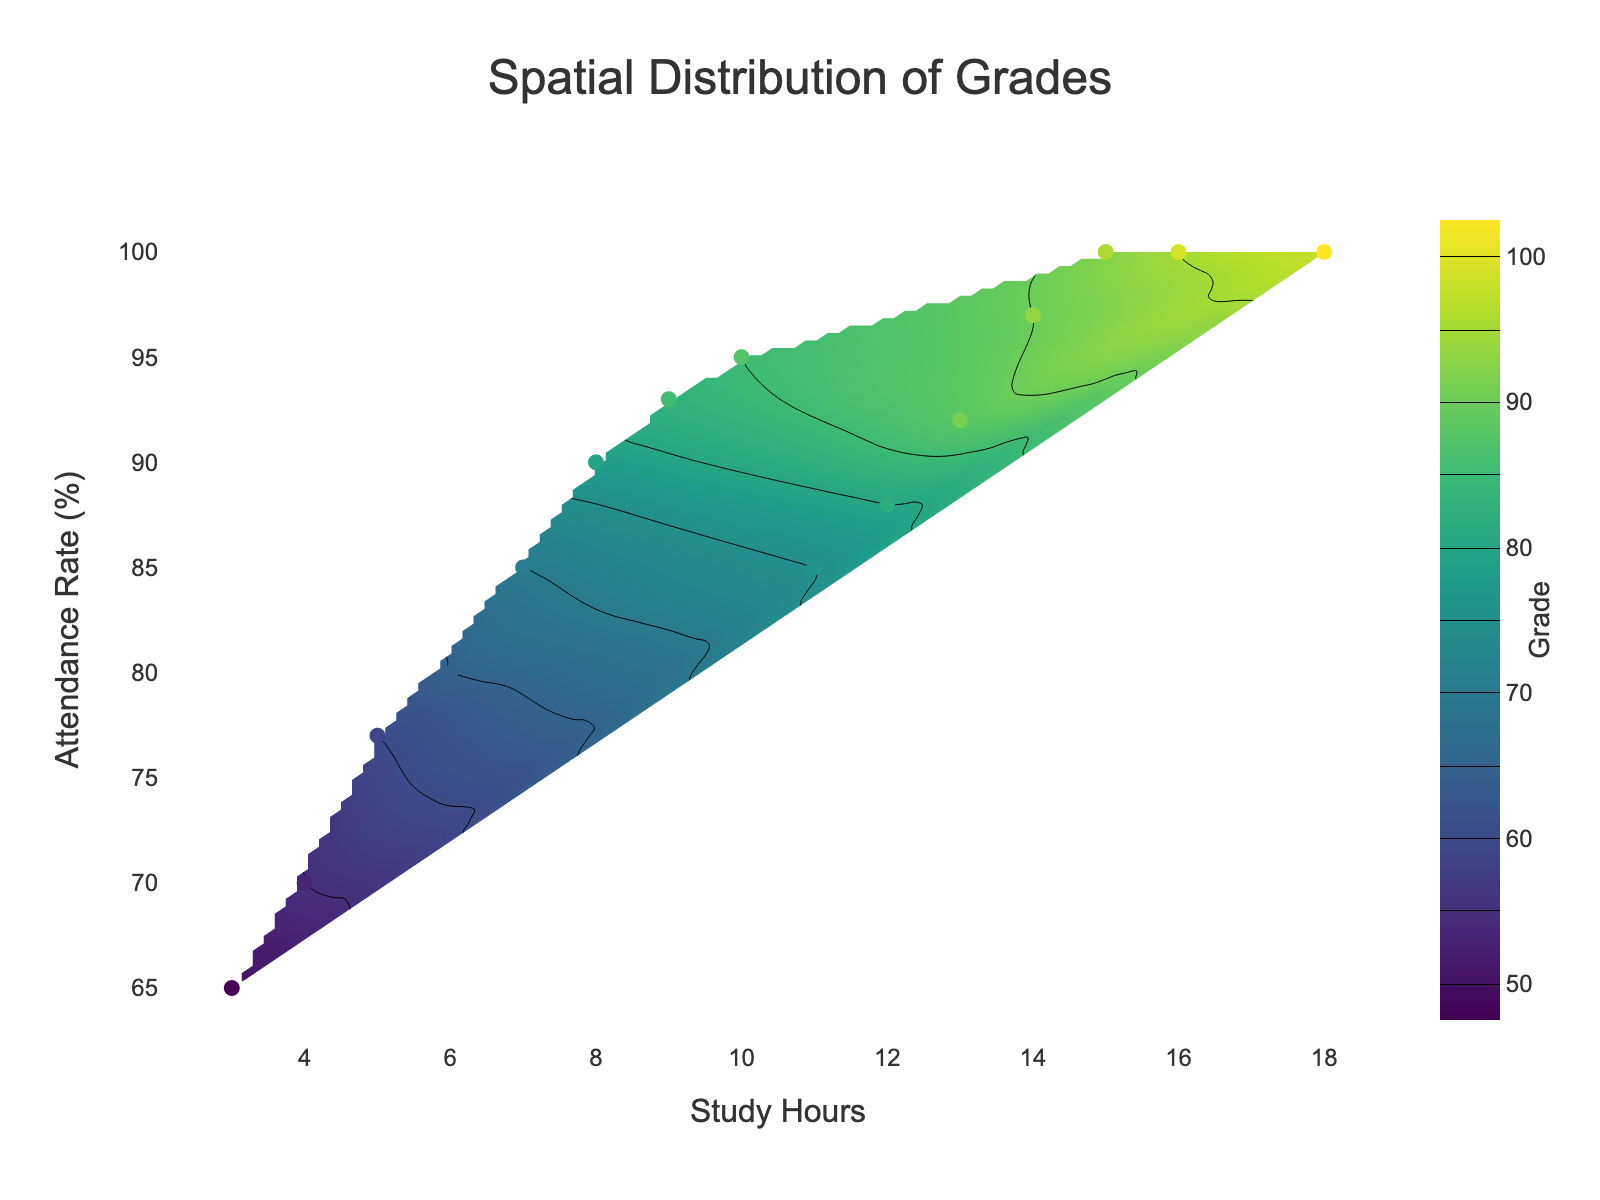What is the title of the figure? The title is usually at the top center of a plot. In this figure, it is displayed prominently in large font.
Answer: Spatial Distribution of Grades What are the units on the x-axis? The label on the x-axis indicates the unit of measurement for study hours, which is simply hours.
Answer: Study Hours What range of attendance rates is represented in the figure? The y-axis, labeled Attendance Rate (%), shows the extent from the lowest to the highest attendance rates. By looking at the minimum and maximum ticks, we can see the range.
Answer: 65% to 100% How many data points are displayed as markers in the figure? Each marker on the contour plot represents a data point. Counting them should give the total number of data points.
Answer: 15 What is the highest grade recorded, and what are the corresponding study hours and attendance rate? Reviewing the markers and their hover information, or observing the color scale on the contour plot, helps locate the highest grade.
Answer: 98, 18, 100 Which region (combination of study hours and attendance rate) would likely lead to a failing grade (below 60)? Contour plots indicate regions of similar values. By examining the areas with the coldest colors on the plot, we can identify regions with grades below 60.
Answer: Low study hours (< 5) and low attendance rates (~65%-70%) Is there a visible correlation between study hours and grades? Observing if there's a trend from lower to higher grades as study hours increase helps in identifying a correlation.
Answer: Yes, positive correlation Compare the pattern of grades at 85% attendance rate with those at 95% attendance rate. Which shows higher grades on average? Reviewing the contour colors and levels at 85% and 95% attendance rate and comparing the corresponding grades helps in determining the difference.
Answer: 95% attendance rate How does an attendance rate of 80% generally affect grades when study hours are between 6 and 10? By examining the warmth of the colors or contours around this region of the plot, the average grades can be inferred.
Answer: Generally lower grades (around 65-75) What is the relationship between the study hours and attendance rate for the student who has a grade of 70? Identifying the marker corresponding to the grade of 70 and noting its study hours and attendance rate provides the answer.
Answer: 7 study hours, 85% attendance rate 